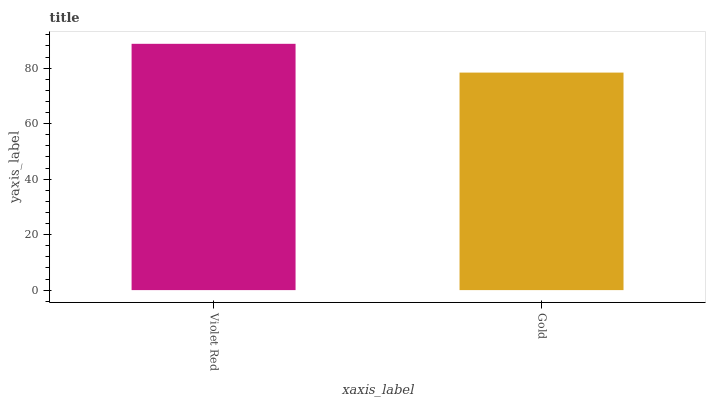Is Gold the maximum?
Answer yes or no. No. Is Violet Red greater than Gold?
Answer yes or no. Yes. Is Gold less than Violet Red?
Answer yes or no. Yes. Is Gold greater than Violet Red?
Answer yes or no. No. Is Violet Red less than Gold?
Answer yes or no. No. Is Violet Red the high median?
Answer yes or no. Yes. Is Gold the low median?
Answer yes or no. Yes. Is Gold the high median?
Answer yes or no. No. Is Violet Red the low median?
Answer yes or no. No. 